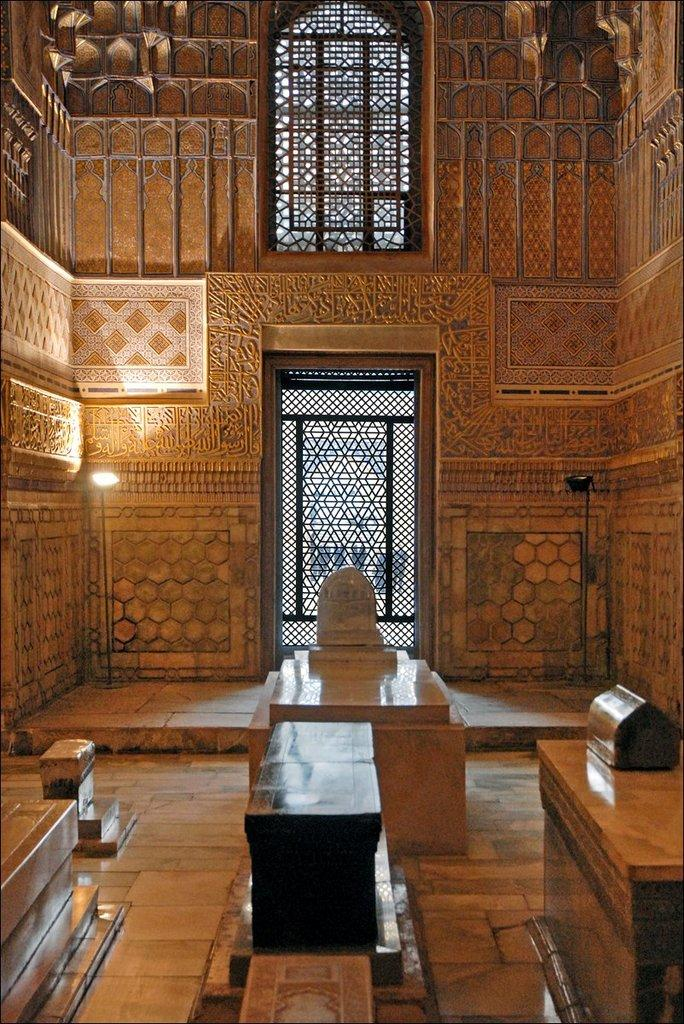What type of structures can be seen in the image? There are tombs in the image. What is visible beneath the tombs? There is a floor visible in the image. What can be seen in the background of the image? There is a designer wall, lights, a window, and a door in the background of the image. What type of owl can be seen sitting on the tomb in the image? There is no owl present in the image; it only features tombs, a floor, and elements in the background. 